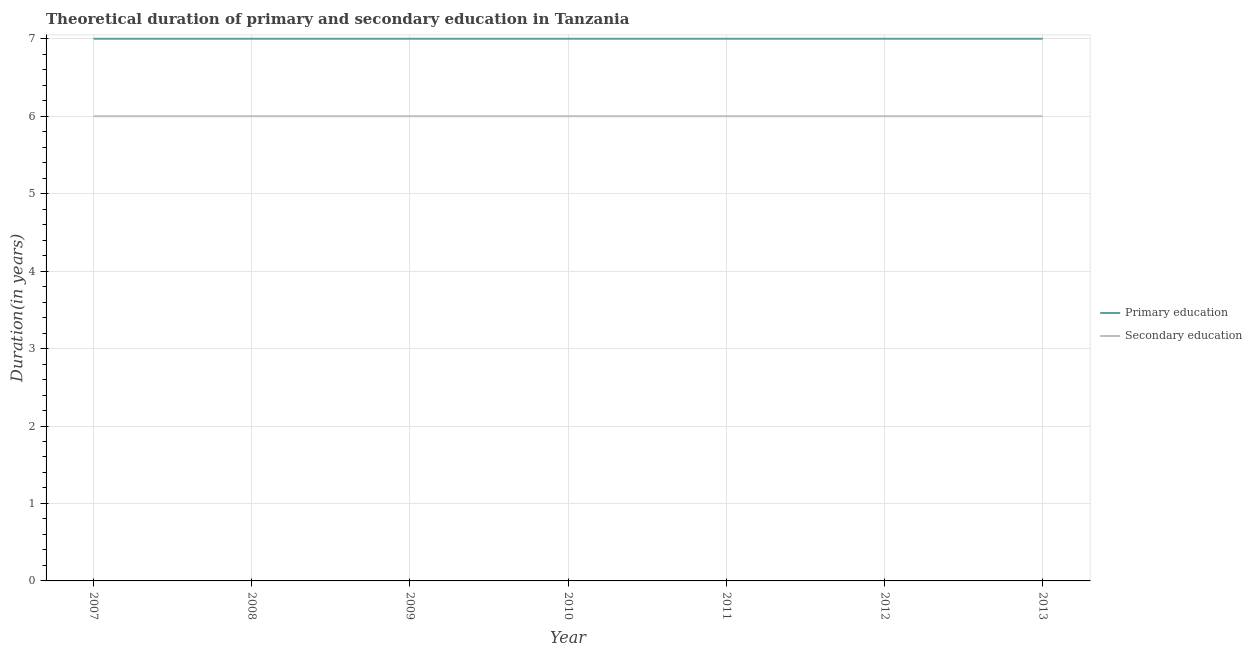Is the number of lines equal to the number of legend labels?
Your answer should be very brief. Yes. What is the duration of primary education in 2009?
Give a very brief answer. 7. Across all years, what is the minimum duration of primary education?
Provide a short and direct response. 7. In which year was the duration of primary education maximum?
Offer a very short reply. 2007. In which year was the duration of primary education minimum?
Offer a very short reply. 2007. What is the total duration of primary education in the graph?
Offer a very short reply. 49. What is the difference between the duration of secondary education in 2008 and that in 2013?
Give a very brief answer. 0. What is the difference between the duration of primary education in 2008 and the duration of secondary education in 2010?
Give a very brief answer. 1. What is the average duration of secondary education per year?
Offer a terse response. 6. In the year 2008, what is the difference between the duration of primary education and duration of secondary education?
Your response must be concise. 1. In how many years, is the duration of primary education greater than 1.2 years?
Make the answer very short. 7. Is the difference between the duration of secondary education in 2007 and 2009 greater than the difference between the duration of primary education in 2007 and 2009?
Keep it short and to the point. No. What is the difference between the highest and the lowest duration of secondary education?
Offer a very short reply. 0. Is the sum of the duration of secondary education in 2009 and 2013 greater than the maximum duration of primary education across all years?
Provide a short and direct response. Yes. Is the duration of primary education strictly greater than the duration of secondary education over the years?
Your answer should be very brief. Yes. How many years are there in the graph?
Offer a terse response. 7. Does the graph contain any zero values?
Ensure brevity in your answer.  No. Where does the legend appear in the graph?
Your response must be concise. Center right. How many legend labels are there?
Keep it short and to the point. 2. How are the legend labels stacked?
Make the answer very short. Vertical. What is the title of the graph?
Ensure brevity in your answer.  Theoretical duration of primary and secondary education in Tanzania. Does "Study and work" appear as one of the legend labels in the graph?
Keep it short and to the point. No. What is the label or title of the X-axis?
Provide a succinct answer. Year. What is the label or title of the Y-axis?
Provide a succinct answer. Duration(in years). What is the Duration(in years) of Primary education in 2009?
Give a very brief answer. 7. What is the Duration(in years) of Primary education in 2011?
Provide a short and direct response. 7. What is the Duration(in years) in Secondary education in 2011?
Ensure brevity in your answer.  6. What is the Duration(in years) in Secondary education in 2013?
Offer a terse response. 6. Across all years, what is the maximum Duration(in years) in Secondary education?
Your answer should be compact. 6. Across all years, what is the minimum Duration(in years) in Primary education?
Your answer should be compact. 7. What is the total Duration(in years) of Primary education in the graph?
Make the answer very short. 49. What is the difference between the Duration(in years) of Secondary education in 2007 and that in 2008?
Ensure brevity in your answer.  0. What is the difference between the Duration(in years) of Primary education in 2007 and that in 2009?
Your answer should be very brief. 0. What is the difference between the Duration(in years) of Secondary education in 2007 and that in 2009?
Your answer should be very brief. 0. What is the difference between the Duration(in years) of Secondary education in 2007 and that in 2011?
Offer a very short reply. 0. What is the difference between the Duration(in years) in Secondary education in 2007 and that in 2012?
Make the answer very short. 0. What is the difference between the Duration(in years) of Primary education in 2008 and that in 2009?
Your answer should be compact. 0. What is the difference between the Duration(in years) in Secondary education in 2008 and that in 2009?
Ensure brevity in your answer.  0. What is the difference between the Duration(in years) in Secondary education in 2008 and that in 2010?
Make the answer very short. 0. What is the difference between the Duration(in years) in Primary education in 2008 and that in 2013?
Your answer should be compact. 0. What is the difference between the Duration(in years) of Secondary education in 2008 and that in 2013?
Keep it short and to the point. 0. What is the difference between the Duration(in years) of Primary education in 2009 and that in 2010?
Make the answer very short. 0. What is the difference between the Duration(in years) of Secondary education in 2009 and that in 2010?
Make the answer very short. 0. What is the difference between the Duration(in years) in Primary education in 2009 and that in 2011?
Provide a short and direct response. 0. What is the difference between the Duration(in years) in Primary education in 2009 and that in 2013?
Your answer should be very brief. 0. What is the difference between the Duration(in years) of Secondary education in 2010 and that in 2011?
Keep it short and to the point. 0. What is the difference between the Duration(in years) in Primary education in 2010 and that in 2012?
Provide a short and direct response. 0. What is the difference between the Duration(in years) of Secondary education in 2010 and that in 2012?
Provide a short and direct response. 0. What is the difference between the Duration(in years) of Primary education in 2010 and that in 2013?
Keep it short and to the point. 0. What is the difference between the Duration(in years) of Primary education in 2011 and that in 2013?
Ensure brevity in your answer.  0. What is the difference between the Duration(in years) of Primary education in 2012 and that in 2013?
Your answer should be very brief. 0. What is the difference between the Duration(in years) in Primary education in 2007 and the Duration(in years) in Secondary education in 2012?
Offer a very short reply. 1. What is the difference between the Duration(in years) of Primary education in 2007 and the Duration(in years) of Secondary education in 2013?
Give a very brief answer. 1. What is the difference between the Duration(in years) of Primary education in 2008 and the Duration(in years) of Secondary education in 2009?
Provide a short and direct response. 1. What is the difference between the Duration(in years) in Primary education in 2008 and the Duration(in years) in Secondary education in 2011?
Offer a terse response. 1. What is the difference between the Duration(in years) of Primary education in 2008 and the Duration(in years) of Secondary education in 2012?
Keep it short and to the point. 1. What is the difference between the Duration(in years) in Primary education in 2009 and the Duration(in years) in Secondary education in 2012?
Keep it short and to the point. 1. What is the difference between the Duration(in years) in Primary education in 2009 and the Duration(in years) in Secondary education in 2013?
Make the answer very short. 1. What is the difference between the Duration(in years) of Primary education in 2010 and the Duration(in years) of Secondary education in 2013?
Offer a very short reply. 1. What is the difference between the Duration(in years) of Primary education in 2011 and the Duration(in years) of Secondary education in 2012?
Give a very brief answer. 1. What is the difference between the Duration(in years) of Primary education in 2011 and the Duration(in years) of Secondary education in 2013?
Provide a succinct answer. 1. In the year 2009, what is the difference between the Duration(in years) of Primary education and Duration(in years) of Secondary education?
Make the answer very short. 1. In the year 2010, what is the difference between the Duration(in years) of Primary education and Duration(in years) of Secondary education?
Provide a short and direct response. 1. In the year 2012, what is the difference between the Duration(in years) in Primary education and Duration(in years) in Secondary education?
Give a very brief answer. 1. In the year 2013, what is the difference between the Duration(in years) of Primary education and Duration(in years) of Secondary education?
Provide a succinct answer. 1. What is the ratio of the Duration(in years) of Secondary education in 2007 to that in 2009?
Make the answer very short. 1. What is the ratio of the Duration(in years) in Secondary education in 2007 to that in 2010?
Offer a terse response. 1. What is the ratio of the Duration(in years) of Primary education in 2007 to that in 2011?
Your answer should be compact. 1. What is the ratio of the Duration(in years) of Primary education in 2007 to that in 2013?
Make the answer very short. 1. What is the ratio of the Duration(in years) in Secondary education in 2007 to that in 2013?
Offer a terse response. 1. What is the ratio of the Duration(in years) in Primary education in 2009 to that in 2010?
Offer a very short reply. 1. What is the ratio of the Duration(in years) of Secondary education in 2009 to that in 2010?
Provide a succinct answer. 1. What is the ratio of the Duration(in years) in Primary education in 2009 to that in 2011?
Give a very brief answer. 1. What is the ratio of the Duration(in years) in Secondary education in 2010 to that in 2011?
Make the answer very short. 1. What is the ratio of the Duration(in years) of Primary education in 2010 to that in 2012?
Your answer should be very brief. 1. What is the ratio of the Duration(in years) in Primary education in 2011 to that in 2013?
Offer a terse response. 1. What is the ratio of the Duration(in years) of Secondary education in 2011 to that in 2013?
Offer a terse response. 1. What is the ratio of the Duration(in years) of Primary education in 2012 to that in 2013?
Your answer should be compact. 1. What is the ratio of the Duration(in years) of Secondary education in 2012 to that in 2013?
Make the answer very short. 1. What is the difference between the highest and the lowest Duration(in years) of Primary education?
Keep it short and to the point. 0. What is the difference between the highest and the lowest Duration(in years) in Secondary education?
Your answer should be compact. 0. 